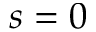<formula> <loc_0><loc_0><loc_500><loc_500>s = 0</formula> 